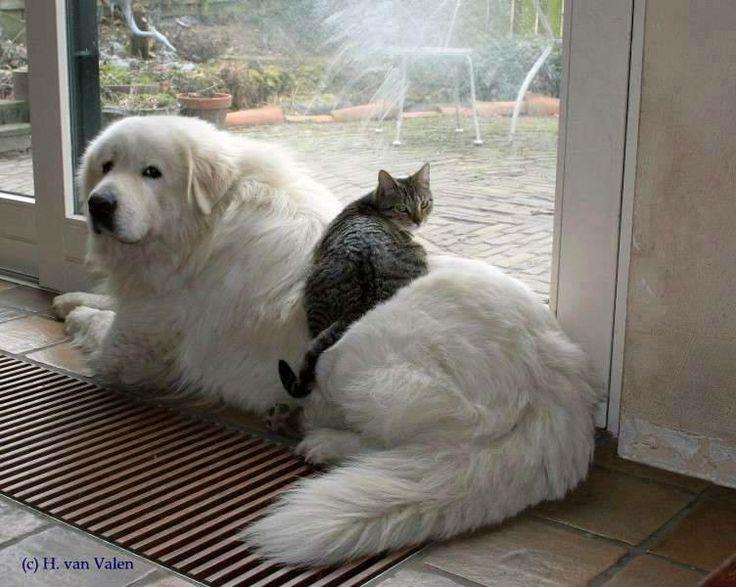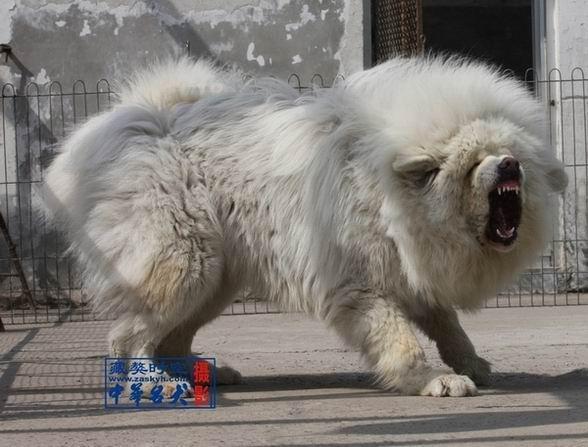The first image is the image on the left, the second image is the image on the right. Evaluate the accuracy of this statement regarding the images: "One dog's mouth is open.". Is it true? Answer yes or no. Yes. The first image is the image on the left, the second image is the image on the right. For the images displayed, is the sentence "at least one dog is on a grass surface" factually correct? Answer yes or no. No. 